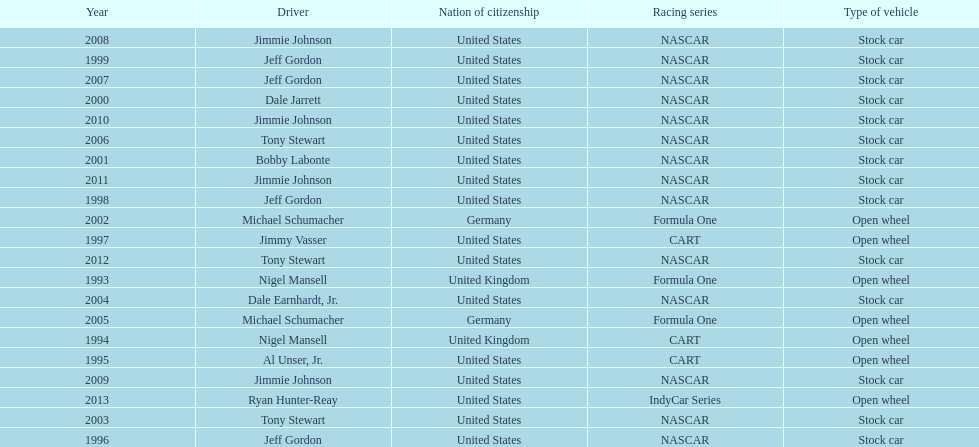How many total row entries are there? 21. Would you mind parsing the complete table? {'header': ['Year', 'Driver', 'Nation of citizenship', 'Racing series', 'Type of vehicle'], 'rows': [['2008', 'Jimmie Johnson', 'United States', 'NASCAR', 'Stock car'], ['1999', 'Jeff Gordon', 'United States', 'NASCAR', 'Stock car'], ['2007', 'Jeff Gordon', 'United States', 'NASCAR', 'Stock car'], ['2000', 'Dale Jarrett', 'United States', 'NASCAR', 'Stock car'], ['2010', 'Jimmie Johnson', 'United States', 'NASCAR', 'Stock car'], ['2006', 'Tony Stewart', 'United States', 'NASCAR', 'Stock car'], ['2001', 'Bobby Labonte', 'United States', 'NASCAR', 'Stock car'], ['2011', 'Jimmie Johnson', 'United States', 'NASCAR', 'Stock car'], ['1998', 'Jeff Gordon', 'United States', 'NASCAR', 'Stock car'], ['2002', 'Michael Schumacher', 'Germany', 'Formula One', 'Open wheel'], ['1997', 'Jimmy Vasser', 'United States', 'CART', 'Open wheel'], ['2012', 'Tony Stewart', 'United States', 'NASCAR', 'Stock car'], ['1993', 'Nigel Mansell', 'United Kingdom', 'Formula One', 'Open wheel'], ['2004', 'Dale Earnhardt, Jr.', 'United States', 'NASCAR', 'Stock car'], ['2005', 'Michael Schumacher', 'Germany', 'Formula One', 'Open wheel'], ['1994', 'Nigel Mansell', 'United Kingdom', 'CART', 'Open wheel'], ['1995', 'Al Unser, Jr.', 'United States', 'CART', 'Open wheel'], ['2009', 'Jimmie Johnson', 'United States', 'NASCAR', 'Stock car'], ['2013', 'Ryan Hunter-Reay', 'United States', 'IndyCar Series', 'Open wheel'], ['2003', 'Tony Stewart', 'United States', 'NASCAR', 'Stock car'], ['1996', 'Jeff Gordon', 'United States', 'NASCAR', 'Stock car']]} 